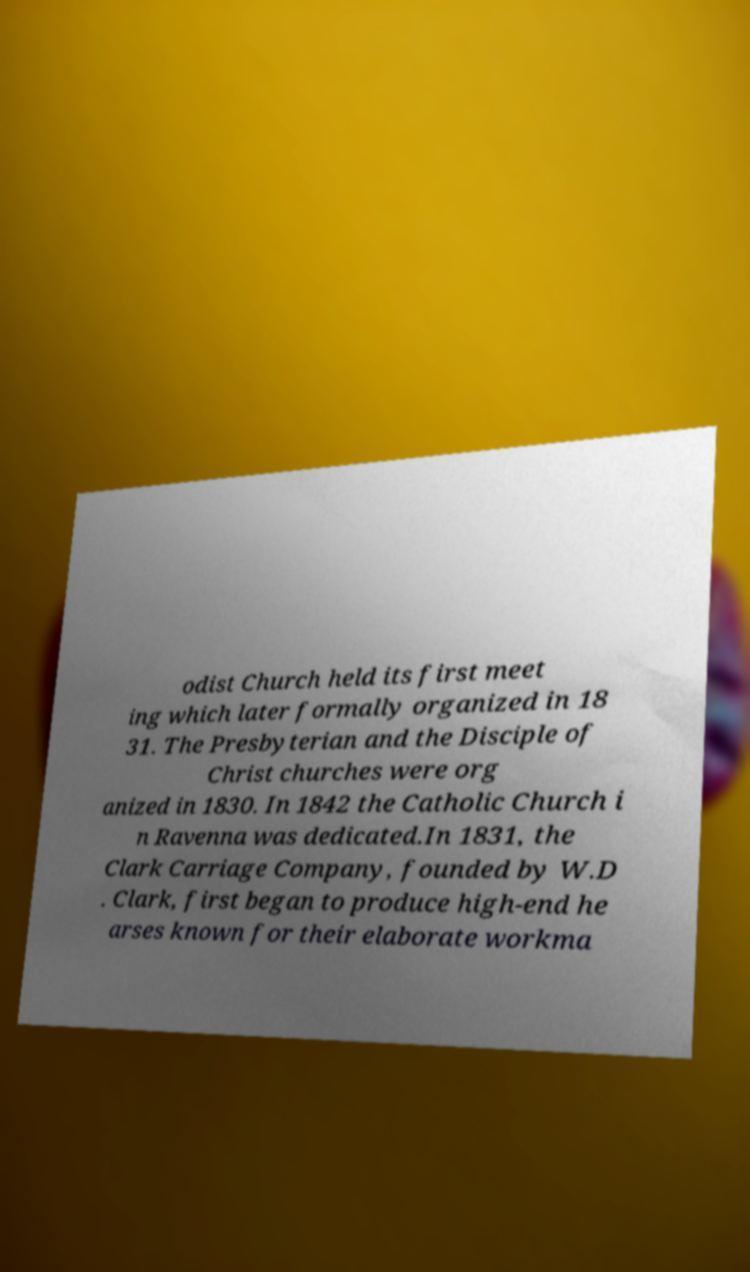What messages or text are displayed in this image? I need them in a readable, typed format. odist Church held its first meet ing which later formally organized in 18 31. The Presbyterian and the Disciple of Christ churches were org anized in 1830. In 1842 the Catholic Church i n Ravenna was dedicated.In 1831, the Clark Carriage Company, founded by W.D . Clark, first began to produce high-end he arses known for their elaborate workma 